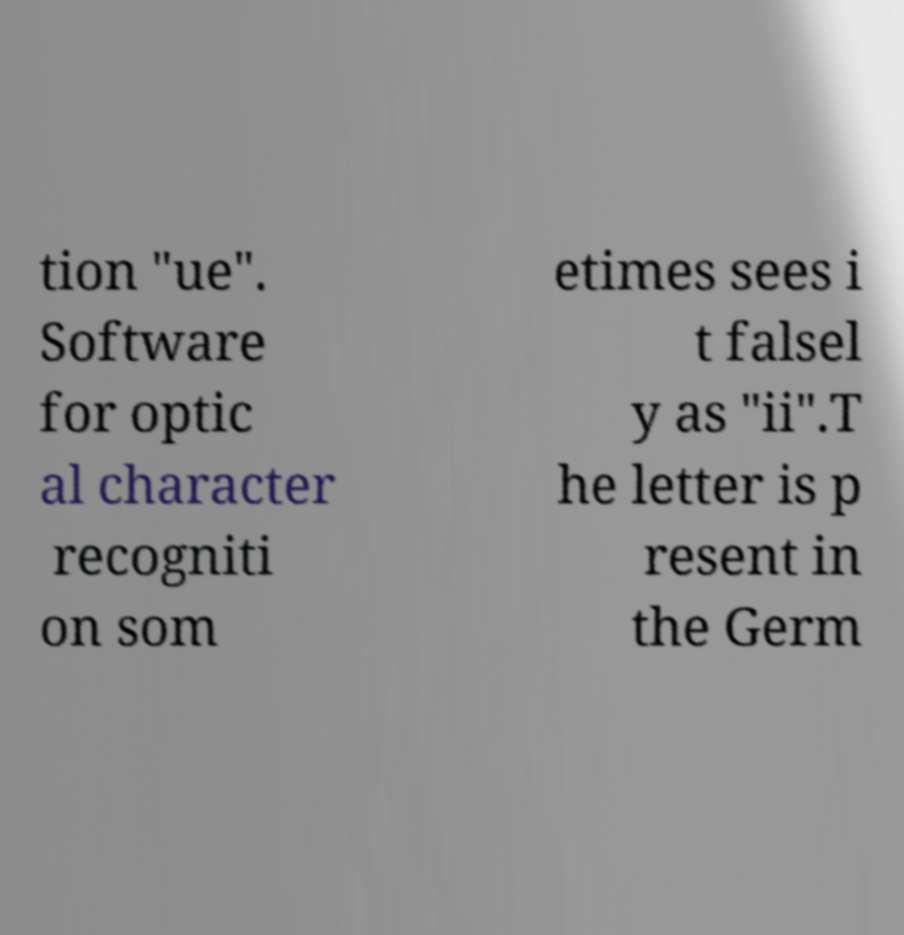Could you extract and type out the text from this image? tion "ue". Software for optic al character recogniti on som etimes sees i t falsel y as "ii".T he letter is p resent in the Germ 